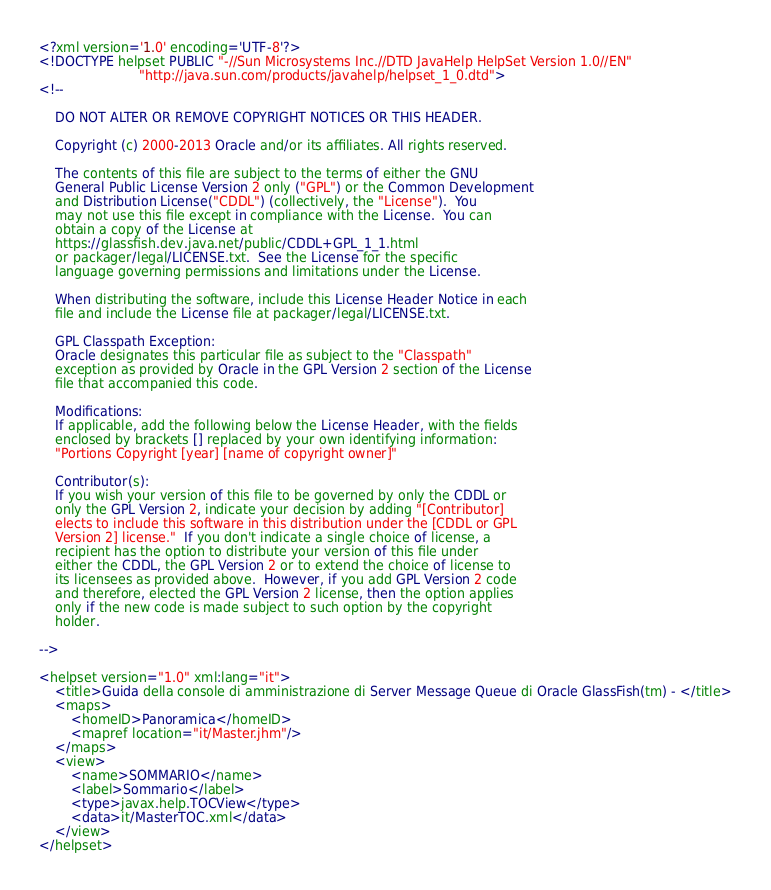<code> <loc_0><loc_0><loc_500><loc_500><_Haskell_><?xml version='1.0' encoding='UTF-8'?>
<!DOCTYPE helpset PUBLIC "-//Sun Microsystems Inc.//DTD JavaHelp HelpSet Version 1.0//EN"
                         "http://java.sun.com/products/javahelp/helpset_1_0.dtd">
<!--

    DO NOT ALTER OR REMOVE COPYRIGHT NOTICES OR THIS HEADER.

    Copyright (c) 2000-2013 Oracle and/or its affiliates. All rights reserved.

    The contents of this file are subject to the terms of either the GNU
    General Public License Version 2 only ("GPL") or the Common Development
    and Distribution License("CDDL") (collectively, the "License").  You
    may not use this file except in compliance with the License.  You can
    obtain a copy of the License at
    https://glassfish.dev.java.net/public/CDDL+GPL_1_1.html
    or packager/legal/LICENSE.txt.  See the License for the specific
    language governing permissions and limitations under the License.

    When distributing the software, include this License Header Notice in each
    file and include the License file at packager/legal/LICENSE.txt.

    GPL Classpath Exception:
    Oracle designates this particular file as subject to the "Classpath"
    exception as provided by Oracle in the GPL Version 2 section of the License
    file that accompanied this code.

    Modifications:
    If applicable, add the following below the License Header, with the fields
    enclosed by brackets [] replaced by your own identifying information:
    "Portions Copyright [year] [name of copyright owner]"

    Contributor(s):
    If you wish your version of this file to be governed by only the CDDL or
    only the GPL Version 2, indicate your decision by adding "[Contributor]
    elects to include this software in this distribution under the [CDDL or GPL
    Version 2] license."  If you don't indicate a single choice of license, a
    recipient has the option to distribute your version of this file under
    either the CDDL, the GPL Version 2 or to extend the choice of license to
    its licensees as provided above.  However, if you add GPL Version 2 code
    and therefore, elected the GPL Version 2 license, then the option applies
    only if the new code is made subject to such option by the copyright
    holder.

-->

<helpset version="1.0" xml:lang="it">
	<title>Guida della console di amministrazione di Server Message Queue di Oracle GlassFish(tm) - </title>
	<maps>
		<homeID>Panoramica</homeID>
		<mapref location="it/Master.jhm"/>
	</maps>
	<view>
		<name>SOMMARIO</name>
		<label>Sommario</label>
		<type>javax.help.TOCView</type>
		<data>it/MasterTOC.xml</data>
	</view>
</helpset>
</code> 